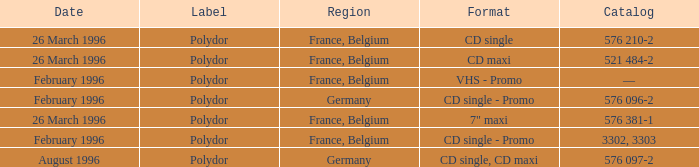Write the full table. {'header': ['Date', 'Label', 'Region', 'Format', 'Catalog'], 'rows': [['26 March 1996', 'Polydor', 'France, Belgium', 'CD single', '576 210-2'], ['26 March 1996', 'Polydor', 'France, Belgium', 'CD maxi', '521 484-2'], ['February 1996', 'Polydor', 'France, Belgium', 'VHS - Promo', '—'], ['February 1996', 'Polydor', 'Germany', 'CD single - Promo', '576 096-2'], ['26 March 1996', 'Polydor', 'France, Belgium', '7" maxi', '576 381-1'], ['February 1996', 'Polydor', 'France, Belgium', 'CD single - Promo', '3302, 3303'], ['August 1996', 'Polydor', 'Germany', 'CD single, CD maxi', '576 097-2']]} Name the catalog for 26 march 1996 576 210-2, 576 381-1, 521 484-2. 